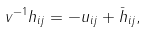Convert formula to latex. <formula><loc_0><loc_0><loc_500><loc_500>v ^ { - 1 } h _ { i j } = - u _ { i j } + \bar { h } _ { i j } ,</formula> 